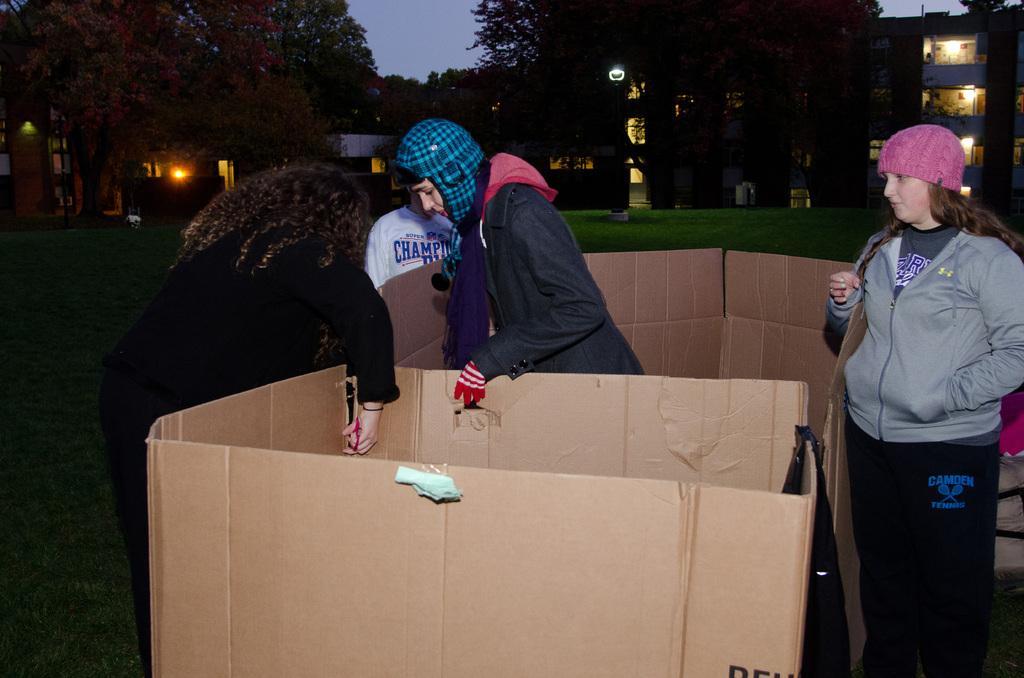Please provide a concise description of this image. In this picture there are buildings and trees and there are lights. In the foreground there is a woman in the cardboard box and there are cardboard boxes and there are three people standing. At the top there is sky. At the bottom there is grass. 